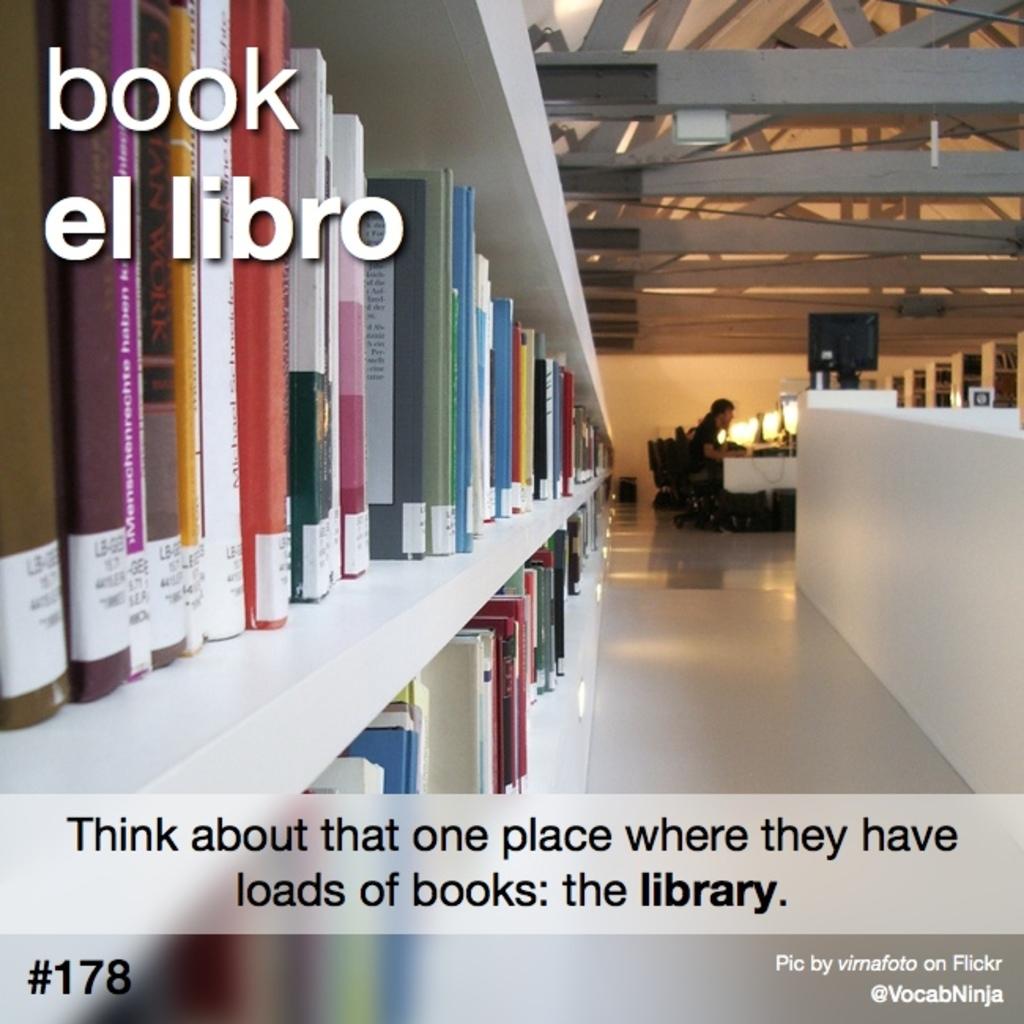Who took this photo?
Offer a terse response. Virnafoto. What is the number in the bottom left?
Give a very brief answer. 178. 